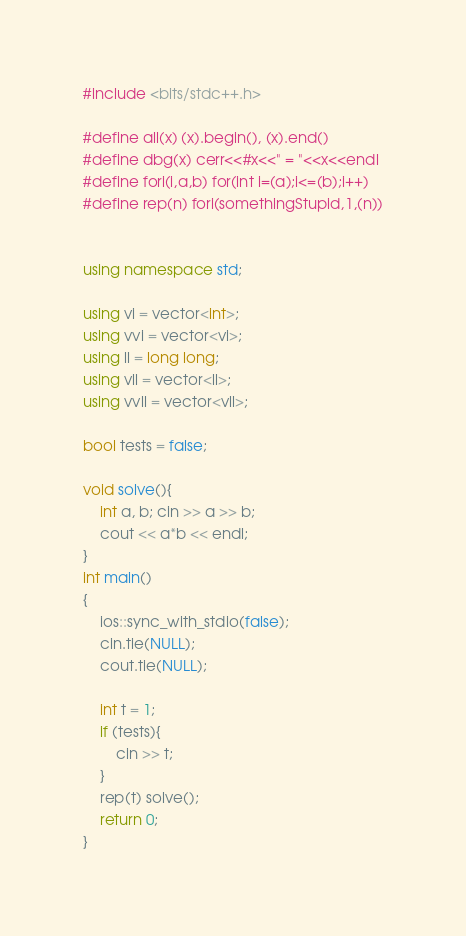<code> <loc_0><loc_0><loc_500><loc_500><_C++_>#include <bits/stdc++.h>

#define all(x) (x).begin(), (x).end()
#define dbg(x) cerr<<#x<<" = "<<x<<endl
#define fori(i,a,b) for(int i=(a);i<=(b);i++)
#define rep(n) fori(somethingStupid,1,(n))


using namespace std;

using vi = vector<int>;
using vvi = vector<vi>;
using ll = long long;
using vll = vector<ll>;
using vvll = vector<vll>;

bool tests = false;

void solve(){
    int a, b; cin >> a >> b;
    cout << a*b << endl;
}
int main()
{
    ios::sync_with_stdio(false);
    cin.tie(NULL);
    cout.tie(NULL);

    int t = 1;
    if (tests){
        cin >> t;
    }
    rep(t) solve();
    return 0;
}
</code> 